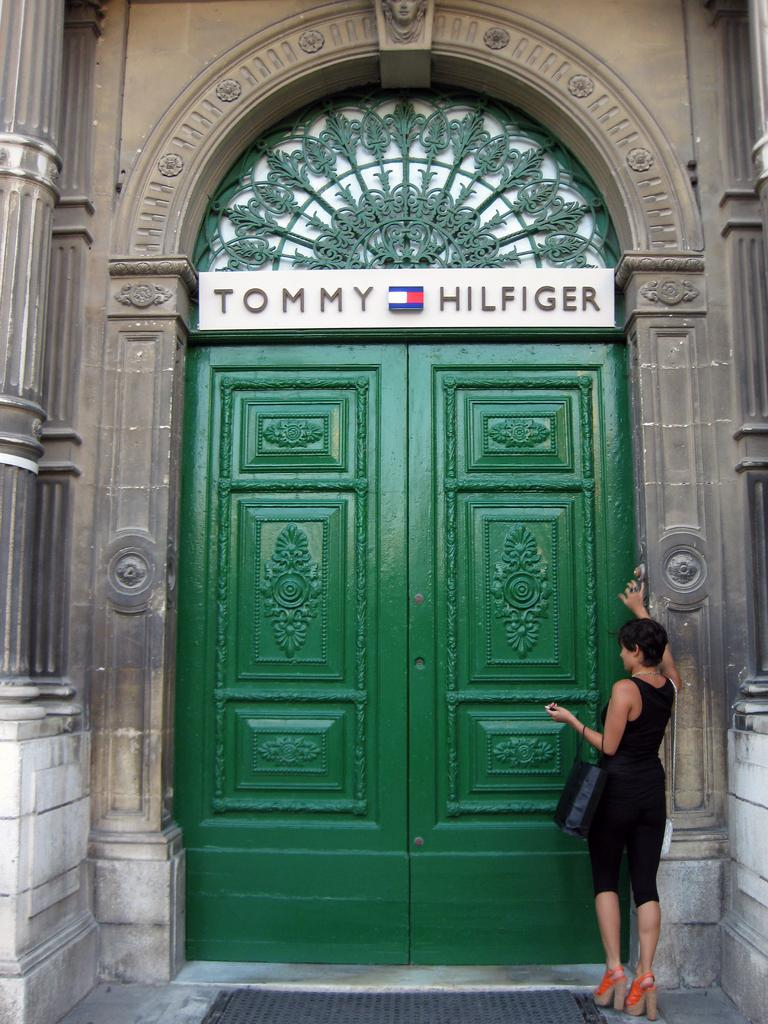Who is present in the image? There is a woman in the image. What is the woman doing in the image? The woman is standing beside a door. What is the woman holding in the image? The woman is holding a bag. What can be seen on the door in the image? There is a name board on the door. What is placed in front of the door in the image? There is a mat in the image. What type of plastic is covering the woman's finger in the image? There is no plastic covering the woman's finger in the image. 